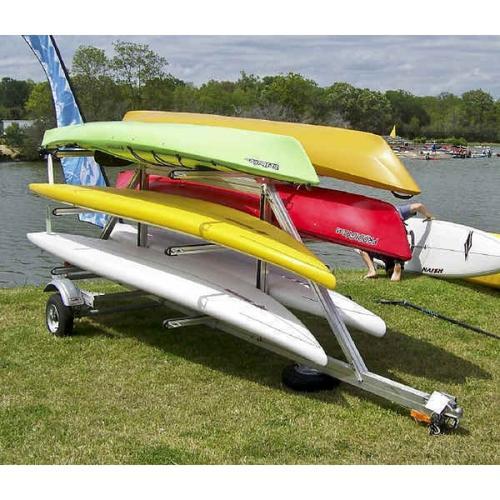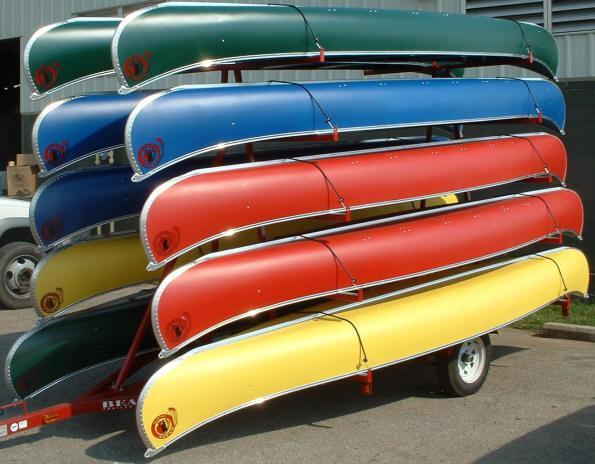The first image is the image on the left, the second image is the image on the right. Given the left and right images, does the statement "At least one canoe is loaded onto a wooden trailer with a black cover in the image on the left." hold true? Answer yes or no. No. 